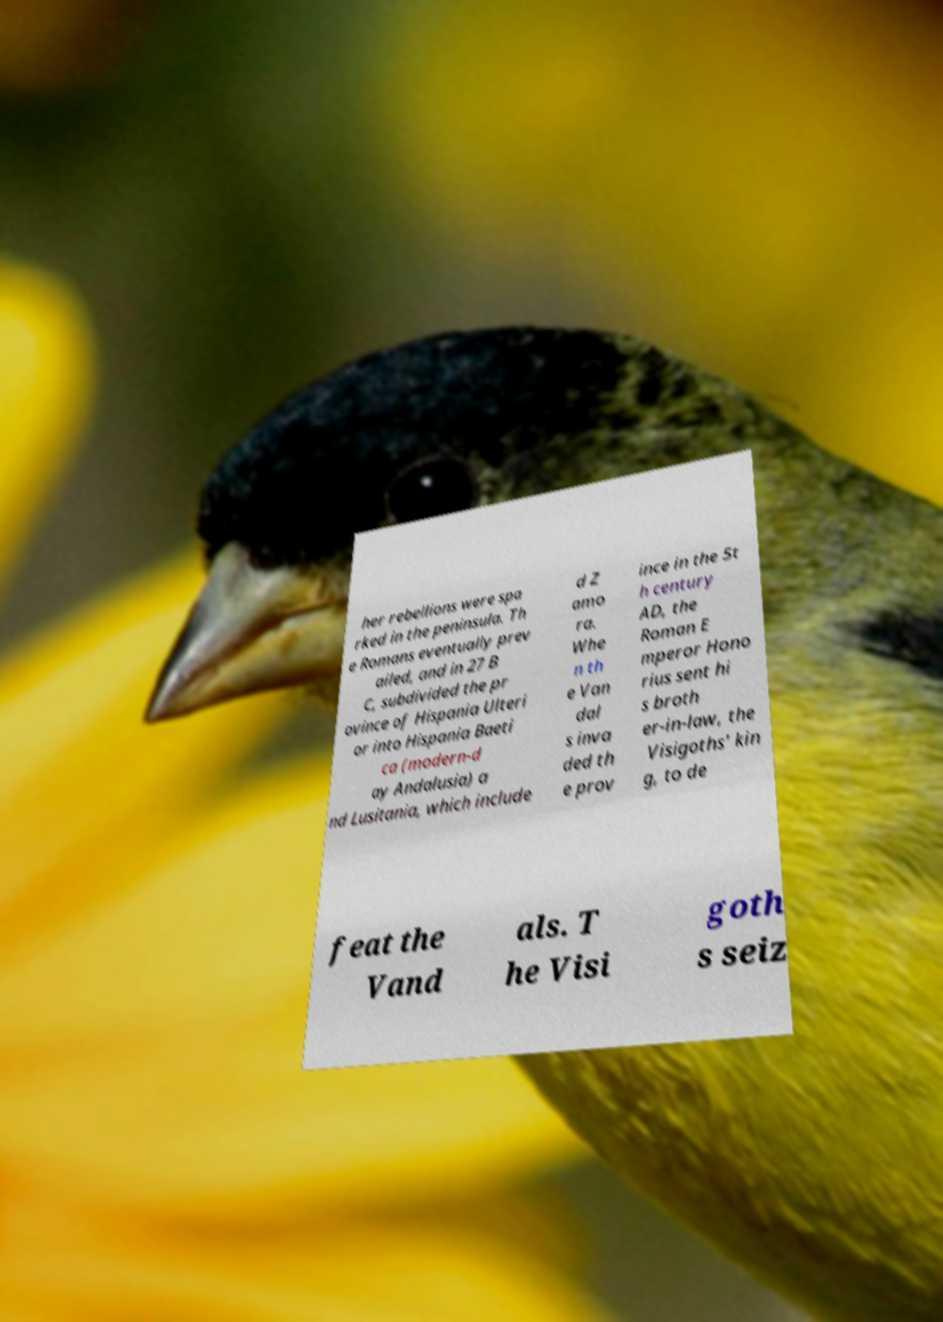I need the written content from this picture converted into text. Can you do that? her rebellions were spa rked in the peninsula. Th e Romans eventually prev ailed, and in 27 B C, subdivided the pr ovince of Hispania Ulteri or into Hispania Baeti ca (modern-d ay Andalusia) a nd Lusitania, which include d Z amo ra. Whe n th e Van dal s inva ded th e prov ince in the 5t h century AD, the Roman E mperor Hono rius sent hi s broth er-in-law, the Visigoths' kin g, to de feat the Vand als. T he Visi goth s seiz 